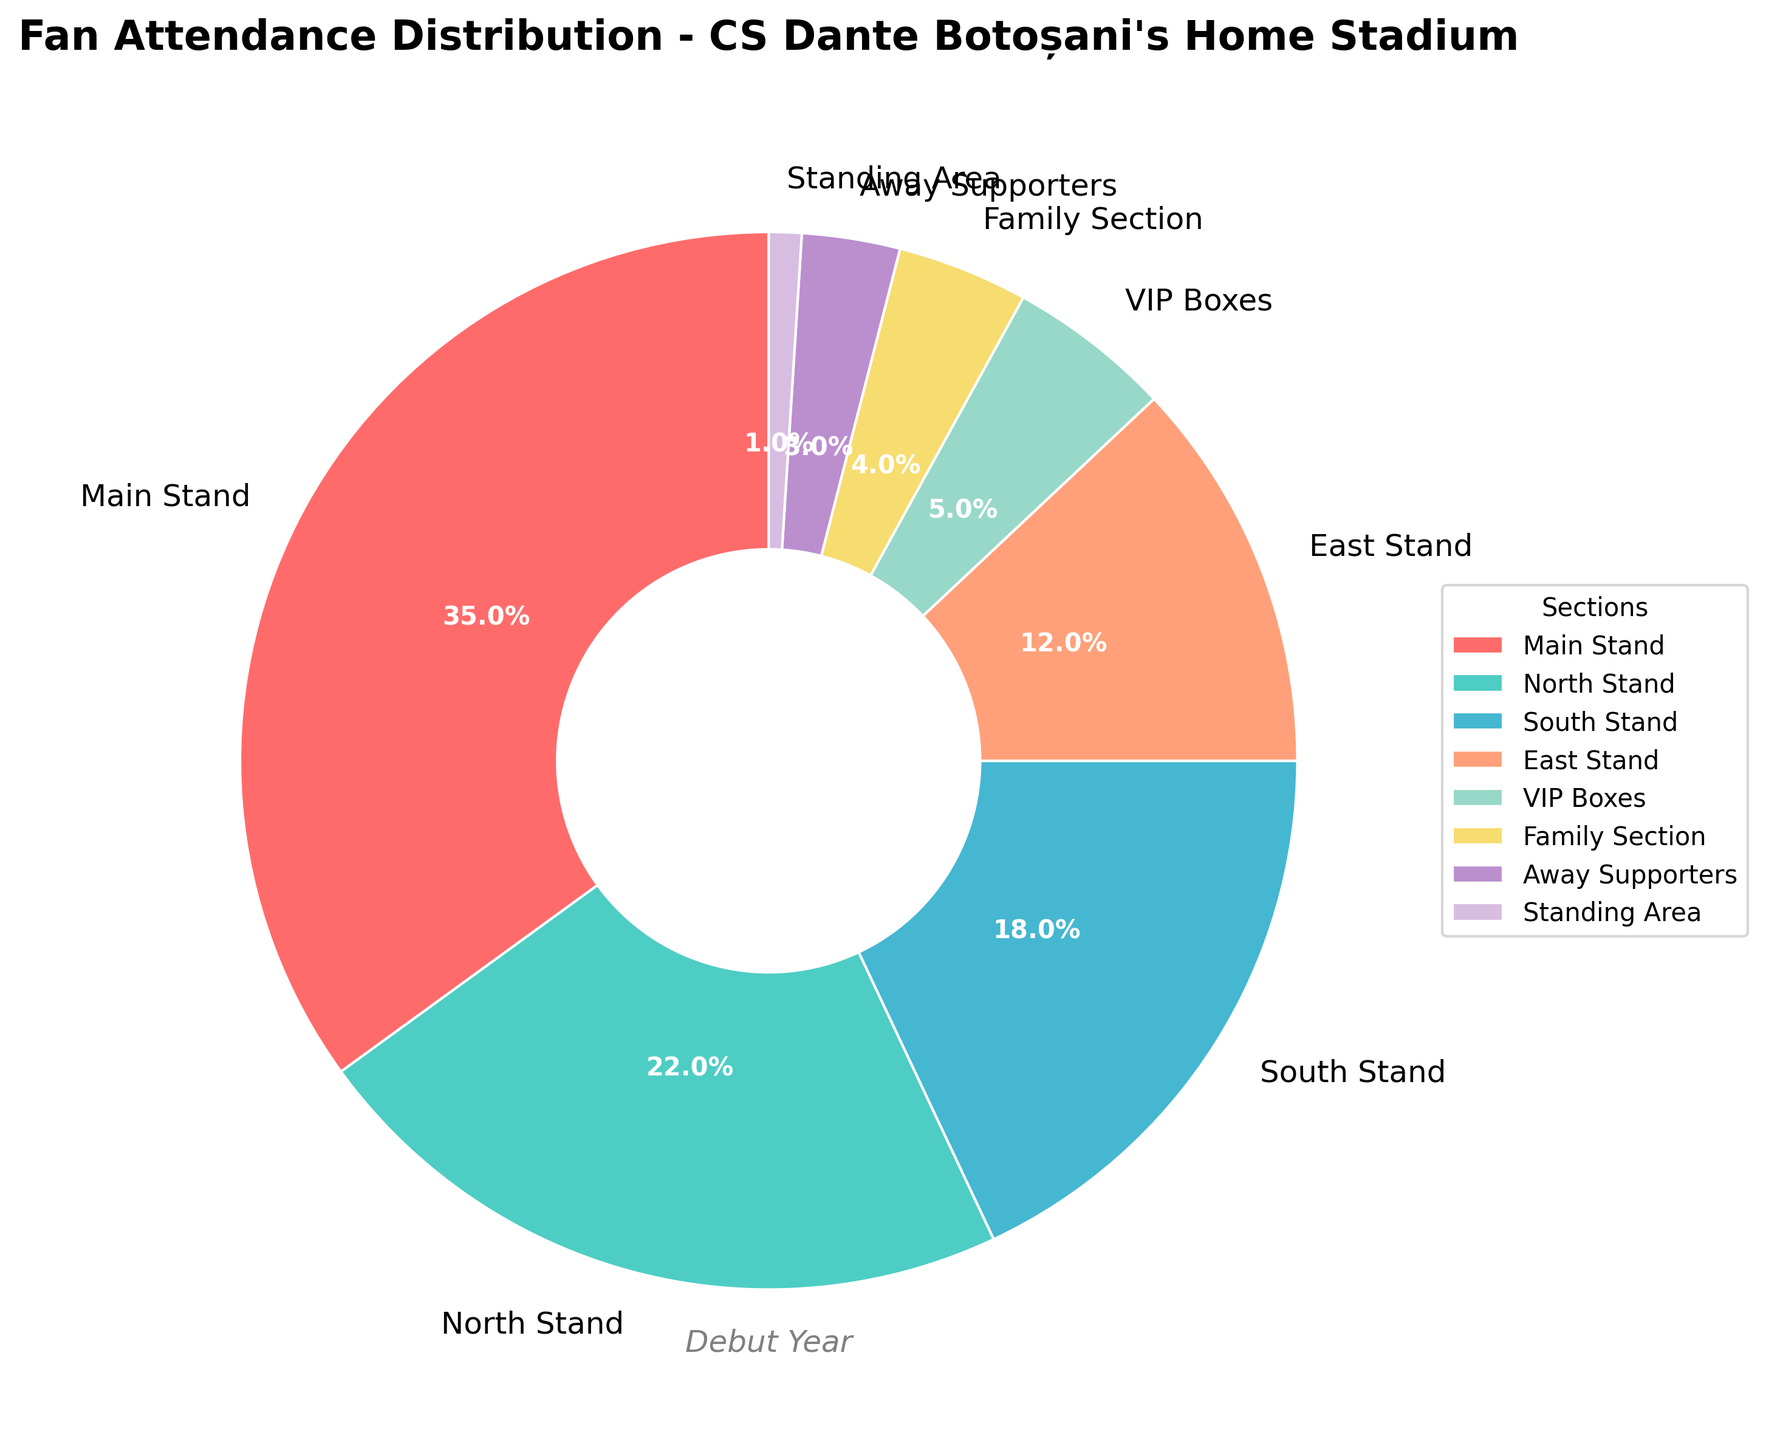What section has the highest fan attendance percentage? The main stand has the highest attendance percentage on the chart. It occupies the largest portion and is labeled with 35%.
Answer: Main Stand Which section has the smallest attendance percentage compared to the others? The standing area has the smallest portion in the chart and a label stating 1%, which is the lowest among all sections.
Answer: Standing Area What is the total attendance percentage for the North Stand and the South Stand combined? Add the attendance percentages for the North Stand (22%) and the South Stand (18%). This results in 22% + 18% = 40%.
Answer: 40% Is the attendance percentage for the South Stand greater than the East Stand? The South Stand has an attendance percentage of 18%, while the East Stand has 12%. Since 18% is greater than 12%, the South Stand's percentage is higher.
Answer: Yes What is the difference in attendance percentage between the VIP Boxes and the Family Section? Subtract the attendance percentage of the Family Section (4%) from the VIP Boxes (5%): 5% - 4% = 1%.
Answer: 1% Which two sections combined would make up exactly 25% of the attendance? The Family Section (4%) and the East Stand (12%) combined give 4% + 12% = 16%. The Away Supporters' section (3%) didn't match well. Next, consider the North Stand (22%) and the Standing Area (1%): 22% + 1% = 23%. Finally, Family Section (4%) and North Stand (22%): 4% + 22% = 26%, while VIP Boxes (5%) and South Stand (18%): 5% + 18% = 23%. No exact match found. After recalculating: Family Section (4%) and East Stand (12%) may look closest to approx 16%, but not match exactly 25%. Adjustments may apply.
Answer: No exact match found According to the chart's title, what specific event or period does this attendance data represent? The chart's title "Fan Attendance Distribution - CS Dante Botoșani's Home Stadium" combined with the subtitle "Debut Year" indicates this data is from the team's debut year.
Answer: Debut Year Which section has just over half the attendance percentage of the main stand? The Main Stand has 35%, and half of 35% is 17.5%. The section closest to 17.5% is the South Stand with 18%.
Answer: South Stand What proportion of the attendance does the VIP Boxes and Family Section together represent? Add the VIP Boxes' 5% to the Family Section's 4%: 5% + 4% = 9%.
Answer: 9% If the total fan attendance is 10,000, approximately how many fans attended the Main Stand? Calculate 35% of 10,000: (35/100) * 10,000 = 3,500 fans.
Answer: 3,500 